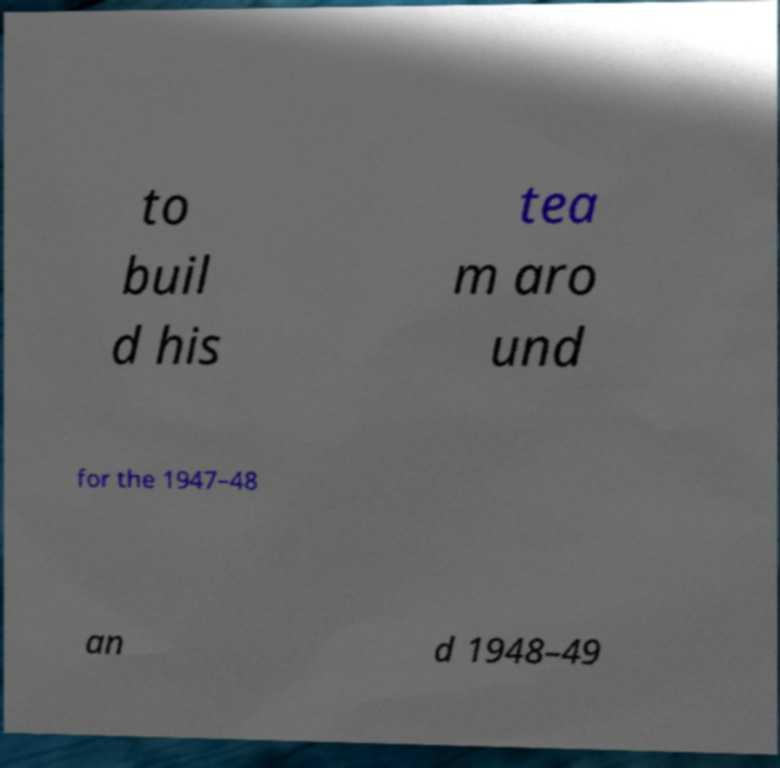I need the written content from this picture converted into text. Can you do that? to buil d his tea m aro und for the 1947–48 an d 1948–49 